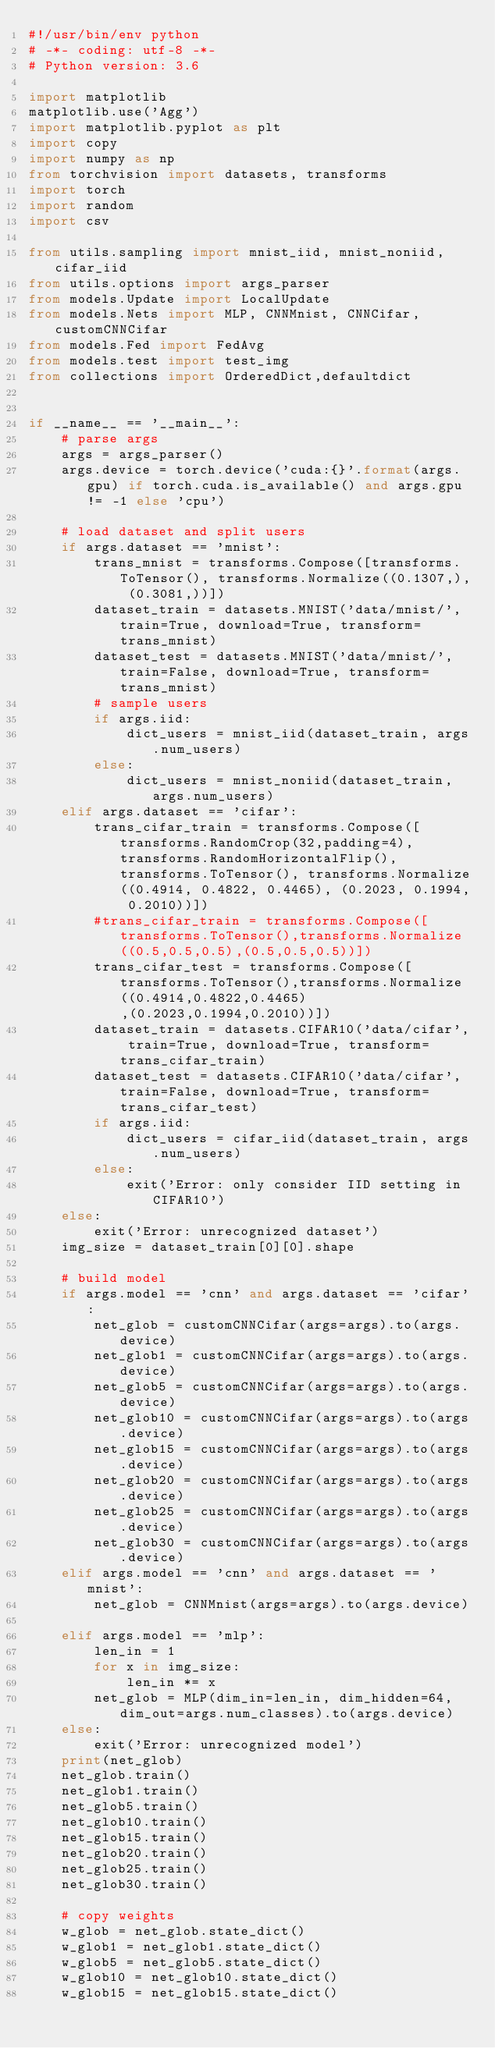Convert code to text. <code><loc_0><loc_0><loc_500><loc_500><_Python_>#!/usr/bin/env python
# -*- coding: utf-8 -*-
# Python version: 3.6

import matplotlib
matplotlib.use('Agg')
import matplotlib.pyplot as plt
import copy
import numpy as np
from torchvision import datasets, transforms
import torch
import random
import csv

from utils.sampling import mnist_iid, mnist_noniid, cifar_iid
from utils.options import args_parser
from models.Update import LocalUpdate
from models.Nets import MLP, CNNMnist, CNNCifar, customCNNCifar
from models.Fed import FedAvg
from models.test import test_img
from collections import OrderedDict,defaultdict


if __name__ == '__main__':
    # parse args
    args = args_parser()
    args.device = torch.device('cuda:{}'.format(args.gpu) if torch.cuda.is_available() and args.gpu != -1 else 'cpu')

    # load dataset and split users
    if args.dataset == 'mnist':
        trans_mnist = transforms.Compose([transforms.ToTensor(), transforms.Normalize((0.1307,), (0.3081,))])
        dataset_train = datasets.MNIST('data/mnist/', train=True, download=True, transform=trans_mnist)
        dataset_test = datasets.MNIST('data/mnist/', train=False, download=True, transform=trans_mnist)
        # sample users
        if args.iid:
            dict_users = mnist_iid(dataset_train, args.num_users)
        else:
            dict_users = mnist_noniid(dataset_train, args.num_users)
    elif args.dataset == 'cifar':
        trans_cifar_train = transforms.Compose([transforms.RandomCrop(32,padding=4),transforms.RandomHorizontalFlip(),transforms.ToTensor(), transforms.Normalize((0.4914, 0.4822, 0.4465), (0.2023, 0.1994, 0.2010))])
        #trans_cifar_train = transforms.Compose([transforms.ToTensor(),transforms.Normalize((0.5,0.5,0.5),(0.5,0.5,0.5))])
        trans_cifar_test = transforms.Compose([transforms.ToTensor(),transforms.Normalize((0.4914,0.4822,0.4465),(0.2023,0.1994,0.2010))])
        dataset_train = datasets.CIFAR10('data/cifar', train=True, download=True, transform=trans_cifar_train)
        dataset_test = datasets.CIFAR10('data/cifar', train=False, download=True, transform=trans_cifar_test)
        if args.iid:
            dict_users = cifar_iid(dataset_train, args.num_users)
        else:
            exit('Error: only consider IID setting in CIFAR10')
    else:
        exit('Error: unrecognized dataset')
    img_size = dataset_train[0][0].shape

    # build model
    if args.model == 'cnn' and args.dataset == 'cifar':
        net_glob = customCNNCifar(args=args).to(args.device)
        net_glob1 = customCNNCifar(args=args).to(args.device)
        net_glob5 = customCNNCifar(args=args).to(args.device)
        net_glob10 = customCNNCifar(args=args).to(args.device)
        net_glob15 = customCNNCifar(args=args).to(args.device)
        net_glob20 = customCNNCifar(args=args).to(args.device)
        net_glob25 = customCNNCifar(args=args).to(args.device)
        net_glob30 = customCNNCifar(args=args).to(args.device)
    elif args.model == 'cnn' and args.dataset == 'mnist':
        net_glob = CNNMnist(args=args).to(args.device)

    elif args.model == 'mlp':
        len_in = 1
        for x in img_size:
            len_in *= x
        net_glob = MLP(dim_in=len_in, dim_hidden=64, dim_out=args.num_classes).to(args.device)
    else:
        exit('Error: unrecognized model')
    print(net_glob)
    net_glob.train()
    net_glob1.train()
    net_glob5.train()
    net_glob10.train()
    net_glob15.train()
    net_glob20.train()
    net_glob25.train()
    net_glob30.train()

    # copy weights
    w_glob = net_glob.state_dict()
    w_glob1 = net_glob1.state_dict()
    w_glob5 = net_glob5.state_dict()
    w_glob10 = net_glob10.state_dict()
    w_glob15 = net_glob15.state_dict()</code> 